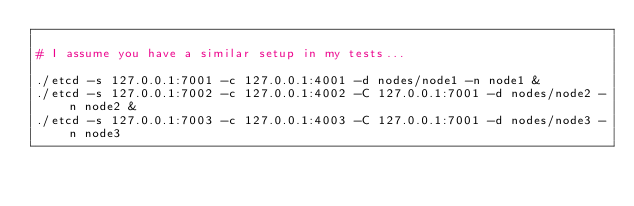Convert code to text. <code><loc_0><loc_0><loc_500><loc_500><_Bash_>
# I assume you have a similar setup in my tests...

./etcd -s 127.0.0.1:7001 -c 127.0.0.1:4001 -d nodes/node1 -n node1 &
./etcd -s 127.0.0.1:7002 -c 127.0.0.1:4002 -C 127.0.0.1:7001 -d nodes/node2 -n node2 &
./etcd -s 127.0.0.1:7003 -c 127.0.0.1:4003 -C 127.0.0.1:7001 -d nodes/node3 -n node3
</code> 